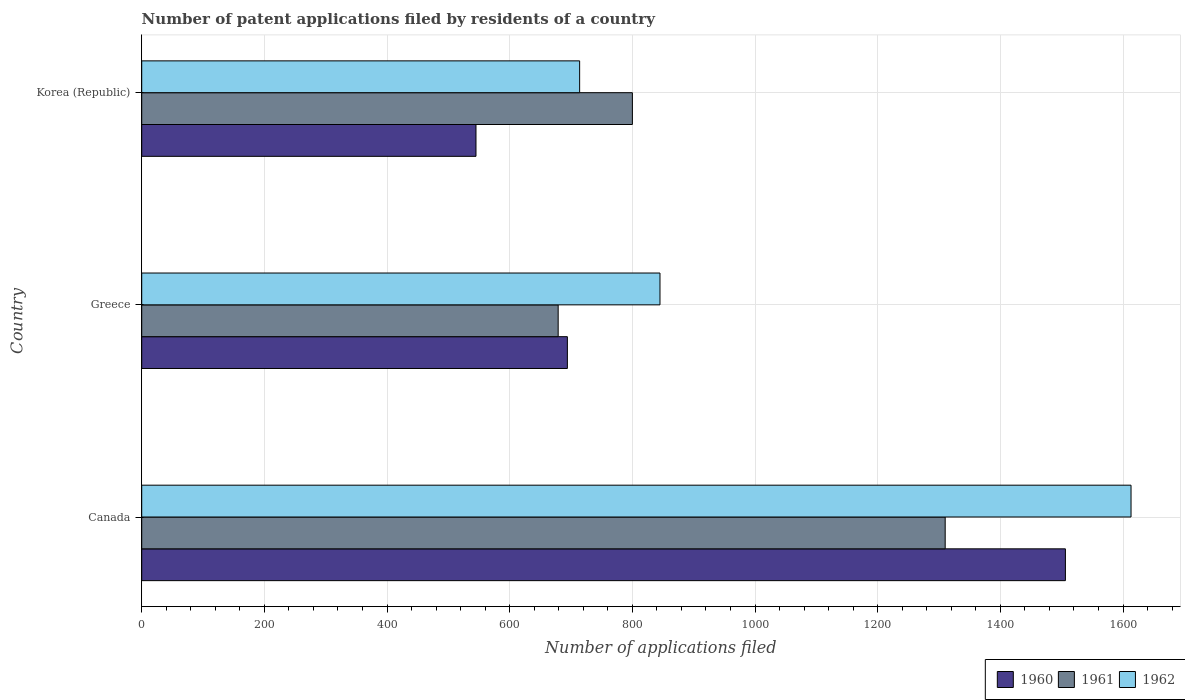How many groups of bars are there?
Your response must be concise. 3. Are the number of bars on each tick of the Y-axis equal?
Ensure brevity in your answer.  Yes. How many bars are there on the 3rd tick from the bottom?
Offer a terse response. 3. In how many cases, is the number of bars for a given country not equal to the number of legend labels?
Your answer should be very brief. 0. What is the number of applications filed in 1962 in Greece?
Keep it short and to the point. 845. Across all countries, what is the maximum number of applications filed in 1962?
Ensure brevity in your answer.  1613. Across all countries, what is the minimum number of applications filed in 1961?
Keep it short and to the point. 679. In which country was the number of applications filed in 1961 minimum?
Provide a short and direct response. Greece. What is the total number of applications filed in 1962 in the graph?
Your response must be concise. 3172. What is the difference between the number of applications filed in 1960 in Canada and that in Korea (Republic)?
Make the answer very short. 961. What is the difference between the number of applications filed in 1962 in Greece and the number of applications filed in 1960 in Korea (Republic)?
Provide a short and direct response. 300. What is the average number of applications filed in 1962 per country?
Your response must be concise. 1057.33. What is the difference between the number of applications filed in 1960 and number of applications filed in 1962 in Canada?
Make the answer very short. -107. In how many countries, is the number of applications filed in 1961 greater than 640 ?
Your answer should be compact. 3. What is the ratio of the number of applications filed in 1962 in Canada to that in Greece?
Provide a succinct answer. 1.91. Is the number of applications filed in 1962 in Canada less than that in Greece?
Keep it short and to the point. No. Is the difference between the number of applications filed in 1960 in Canada and Korea (Republic) greater than the difference between the number of applications filed in 1962 in Canada and Korea (Republic)?
Provide a short and direct response. Yes. What is the difference between the highest and the second highest number of applications filed in 1960?
Provide a short and direct response. 812. What is the difference between the highest and the lowest number of applications filed in 1962?
Your answer should be very brief. 899. What does the 1st bar from the top in Canada represents?
Offer a very short reply. 1962. What does the 3rd bar from the bottom in Canada represents?
Provide a short and direct response. 1962. How many bars are there?
Give a very brief answer. 9. Are all the bars in the graph horizontal?
Make the answer very short. Yes. How many countries are there in the graph?
Provide a short and direct response. 3. What is the difference between two consecutive major ticks on the X-axis?
Keep it short and to the point. 200. Does the graph contain grids?
Your answer should be compact. Yes. How are the legend labels stacked?
Provide a short and direct response. Horizontal. What is the title of the graph?
Offer a very short reply. Number of patent applications filed by residents of a country. What is the label or title of the X-axis?
Your answer should be very brief. Number of applications filed. What is the Number of applications filed in 1960 in Canada?
Ensure brevity in your answer.  1506. What is the Number of applications filed in 1961 in Canada?
Keep it short and to the point. 1310. What is the Number of applications filed in 1962 in Canada?
Offer a very short reply. 1613. What is the Number of applications filed in 1960 in Greece?
Your response must be concise. 694. What is the Number of applications filed in 1961 in Greece?
Keep it short and to the point. 679. What is the Number of applications filed of 1962 in Greece?
Give a very brief answer. 845. What is the Number of applications filed in 1960 in Korea (Republic)?
Provide a short and direct response. 545. What is the Number of applications filed of 1961 in Korea (Republic)?
Keep it short and to the point. 800. What is the Number of applications filed of 1962 in Korea (Republic)?
Your response must be concise. 714. Across all countries, what is the maximum Number of applications filed in 1960?
Provide a succinct answer. 1506. Across all countries, what is the maximum Number of applications filed in 1961?
Make the answer very short. 1310. Across all countries, what is the maximum Number of applications filed of 1962?
Offer a terse response. 1613. Across all countries, what is the minimum Number of applications filed in 1960?
Your answer should be compact. 545. Across all countries, what is the minimum Number of applications filed in 1961?
Give a very brief answer. 679. Across all countries, what is the minimum Number of applications filed in 1962?
Offer a terse response. 714. What is the total Number of applications filed in 1960 in the graph?
Make the answer very short. 2745. What is the total Number of applications filed in 1961 in the graph?
Make the answer very short. 2789. What is the total Number of applications filed in 1962 in the graph?
Offer a terse response. 3172. What is the difference between the Number of applications filed in 1960 in Canada and that in Greece?
Offer a very short reply. 812. What is the difference between the Number of applications filed of 1961 in Canada and that in Greece?
Offer a very short reply. 631. What is the difference between the Number of applications filed of 1962 in Canada and that in Greece?
Provide a succinct answer. 768. What is the difference between the Number of applications filed in 1960 in Canada and that in Korea (Republic)?
Your response must be concise. 961. What is the difference between the Number of applications filed of 1961 in Canada and that in Korea (Republic)?
Keep it short and to the point. 510. What is the difference between the Number of applications filed of 1962 in Canada and that in Korea (Republic)?
Provide a short and direct response. 899. What is the difference between the Number of applications filed of 1960 in Greece and that in Korea (Republic)?
Your answer should be compact. 149. What is the difference between the Number of applications filed in 1961 in Greece and that in Korea (Republic)?
Provide a short and direct response. -121. What is the difference between the Number of applications filed in 1962 in Greece and that in Korea (Republic)?
Your answer should be compact. 131. What is the difference between the Number of applications filed in 1960 in Canada and the Number of applications filed in 1961 in Greece?
Your answer should be very brief. 827. What is the difference between the Number of applications filed of 1960 in Canada and the Number of applications filed of 1962 in Greece?
Provide a short and direct response. 661. What is the difference between the Number of applications filed in 1961 in Canada and the Number of applications filed in 1962 in Greece?
Your answer should be compact. 465. What is the difference between the Number of applications filed in 1960 in Canada and the Number of applications filed in 1961 in Korea (Republic)?
Provide a short and direct response. 706. What is the difference between the Number of applications filed of 1960 in Canada and the Number of applications filed of 1962 in Korea (Republic)?
Ensure brevity in your answer.  792. What is the difference between the Number of applications filed of 1961 in Canada and the Number of applications filed of 1962 in Korea (Republic)?
Provide a succinct answer. 596. What is the difference between the Number of applications filed of 1960 in Greece and the Number of applications filed of 1961 in Korea (Republic)?
Your answer should be compact. -106. What is the difference between the Number of applications filed of 1961 in Greece and the Number of applications filed of 1962 in Korea (Republic)?
Your answer should be compact. -35. What is the average Number of applications filed in 1960 per country?
Give a very brief answer. 915. What is the average Number of applications filed of 1961 per country?
Your response must be concise. 929.67. What is the average Number of applications filed in 1962 per country?
Your answer should be very brief. 1057.33. What is the difference between the Number of applications filed of 1960 and Number of applications filed of 1961 in Canada?
Keep it short and to the point. 196. What is the difference between the Number of applications filed of 1960 and Number of applications filed of 1962 in Canada?
Keep it short and to the point. -107. What is the difference between the Number of applications filed in 1961 and Number of applications filed in 1962 in Canada?
Your response must be concise. -303. What is the difference between the Number of applications filed of 1960 and Number of applications filed of 1962 in Greece?
Your response must be concise. -151. What is the difference between the Number of applications filed in 1961 and Number of applications filed in 1962 in Greece?
Offer a terse response. -166. What is the difference between the Number of applications filed in 1960 and Number of applications filed in 1961 in Korea (Republic)?
Give a very brief answer. -255. What is the difference between the Number of applications filed in 1960 and Number of applications filed in 1962 in Korea (Republic)?
Give a very brief answer. -169. What is the difference between the Number of applications filed in 1961 and Number of applications filed in 1962 in Korea (Republic)?
Provide a short and direct response. 86. What is the ratio of the Number of applications filed of 1960 in Canada to that in Greece?
Provide a succinct answer. 2.17. What is the ratio of the Number of applications filed of 1961 in Canada to that in Greece?
Offer a very short reply. 1.93. What is the ratio of the Number of applications filed of 1962 in Canada to that in Greece?
Provide a short and direct response. 1.91. What is the ratio of the Number of applications filed in 1960 in Canada to that in Korea (Republic)?
Make the answer very short. 2.76. What is the ratio of the Number of applications filed of 1961 in Canada to that in Korea (Republic)?
Your answer should be very brief. 1.64. What is the ratio of the Number of applications filed of 1962 in Canada to that in Korea (Republic)?
Provide a succinct answer. 2.26. What is the ratio of the Number of applications filed of 1960 in Greece to that in Korea (Republic)?
Give a very brief answer. 1.27. What is the ratio of the Number of applications filed of 1961 in Greece to that in Korea (Republic)?
Your answer should be compact. 0.85. What is the ratio of the Number of applications filed in 1962 in Greece to that in Korea (Republic)?
Offer a very short reply. 1.18. What is the difference between the highest and the second highest Number of applications filed in 1960?
Provide a succinct answer. 812. What is the difference between the highest and the second highest Number of applications filed in 1961?
Give a very brief answer. 510. What is the difference between the highest and the second highest Number of applications filed of 1962?
Your response must be concise. 768. What is the difference between the highest and the lowest Number of applications filed of 1960?
Make the answer very short. 961. What is the difference between the highest and the lowest Number of applications filed of 1961?
Your answer should be compact. 631. What is the difference between the highest and the lowest Number of applications filed in 1962?
Your answer should be very brief. 899. 